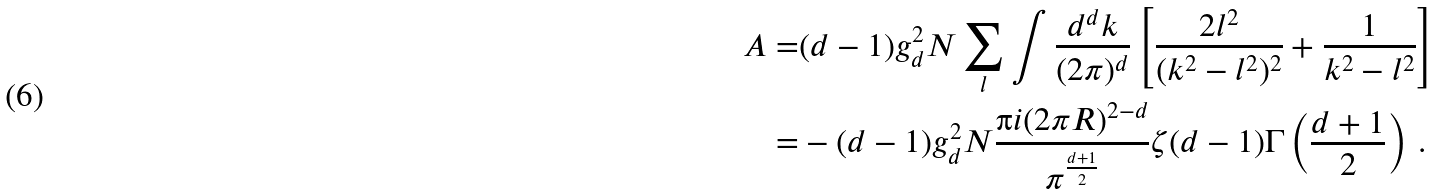Convert formula to latex. <formula><loc_0><loc_0><loc_500><loc_500>A = & ( d - 1 ) g _ { d } ^ { 2 } N \sum _ { l } \int \frac { d ^ { d } k } { ( 2 \pi ) ^ { d } } \left [ \frac { 2 l ^ { 2 } } { ( k ^ { 2 } - l ^ { 2 } ) ^ { 2 } } + \frac { 1 } { k ^ { 2 } - l ^ { 2 } } \right ] \\ = & - ( d - 1 ) g _ { d } ^ { 2 } N \frac { \i i ( 2 \pi R ) ^ { 2 - d } } { \pi ^ { \frac { d + 1 } { 2 } } } \zeta ( d - 1 ) \Gamma \left ( \frac { d + 1 } { 2 } \right ) \, .</formula> 